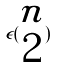<formula> <loc_0><loc_0><loc_500><loc_500>\epsilon ( \begin{matrix} n \\ 2 \end{matrix} )</formula> 